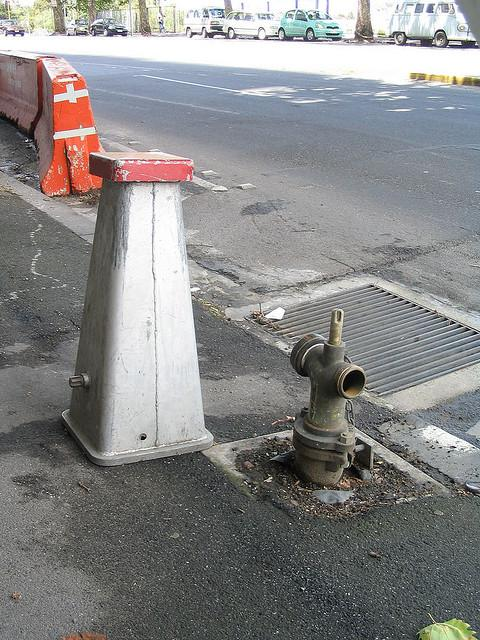What is on the floor? grate 